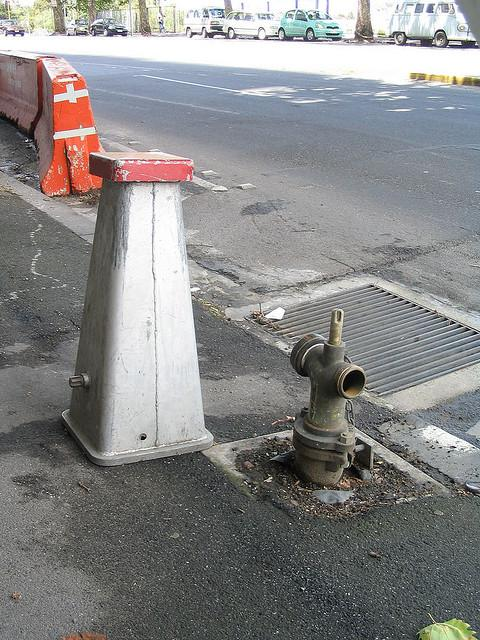What is on the floor? grate 